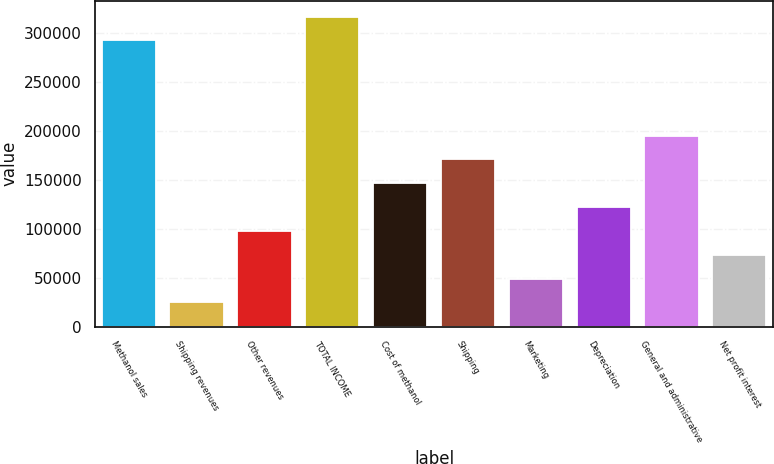Convert chart. <chart><loc_0><loc_0><loc_500><loc_500><bar_chart><fcel>Methanol sales<fcel>Shipping revenues<fcel>Other revenues<fcel>TOTAL INCOME<fcel>Cost of methanol<fcel>Shipping<fcel>Marketing<fcel>Depreciation<fcel>General and administrative<fcel>Net profit interest<nl><fcel>292736<fcel>24699.9<fcel>97800.6<fcel>317103<fcel>146534<fcel>170901<fcel>49066.8<fcel>122168<fcel>195268<fcel>73433.7<nl></chart> 